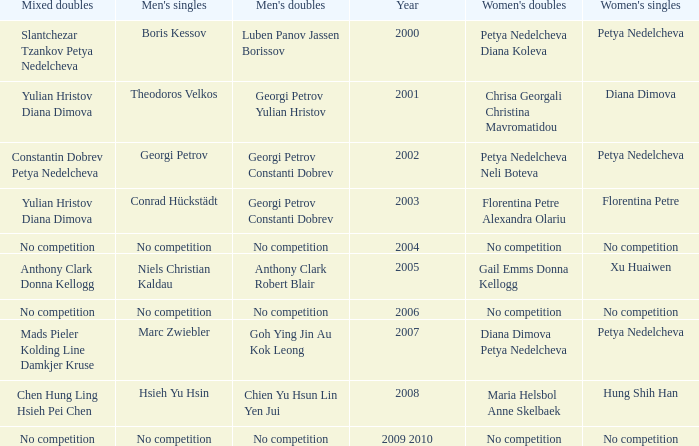Who won the Men's Double the same year as Florentina Petre winning the Women's Singles? Georgi Petrov Constanti Dobrev. 